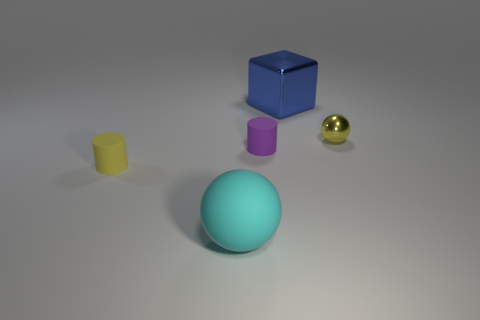Can you describe the lighting and shadows visible in the scene? The lighting in the image appears to be coming from above, casting soft shadows beneath each object. The shadows are slightly elongated, suggesting the light source is not directly overhead but possibly at a slight angle. 